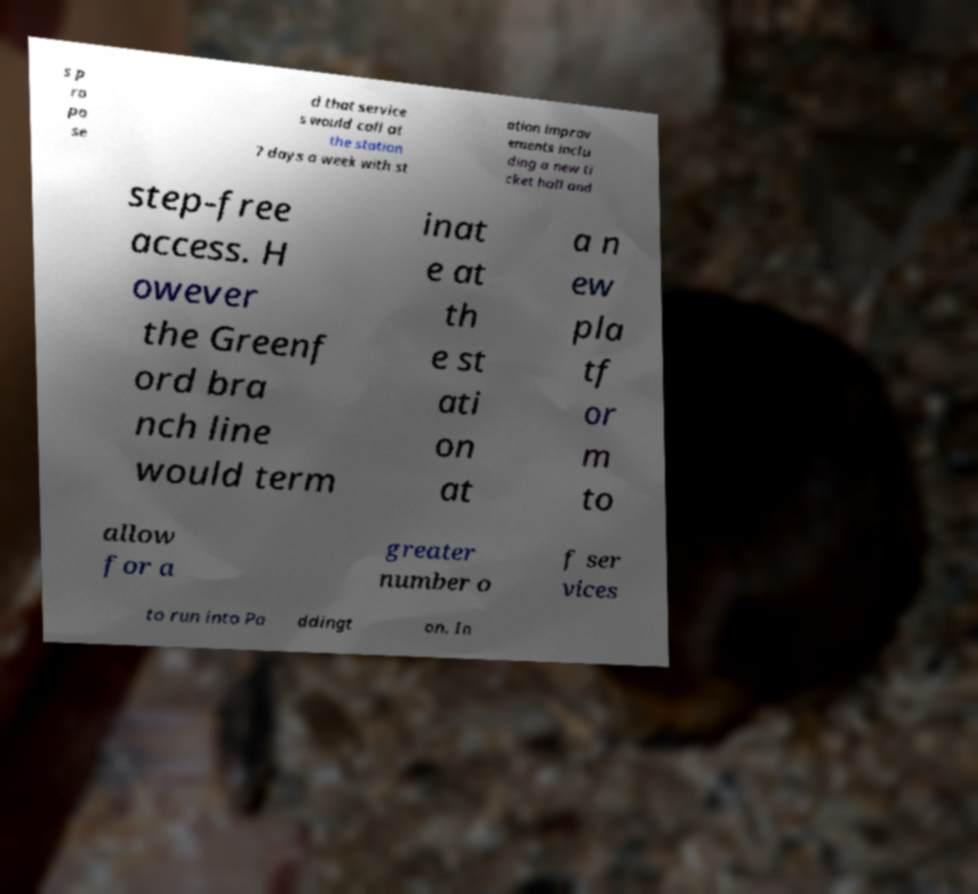Please identify and transcribe the text found in this image. s p ro po se d that service s would call at the station 7 days a week with st ation improv ements inclu ding a new ti cket hall and step-free access. H owever the Greenf ord bra nch line would term inat e at th e st ati on at a n ew pla tf or m to allow for a greater number o f ser vices to run into Pa ddingt on. In 